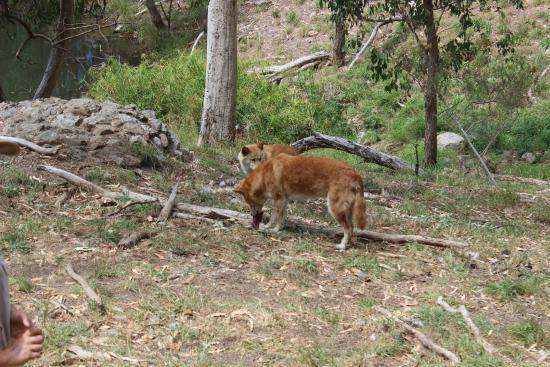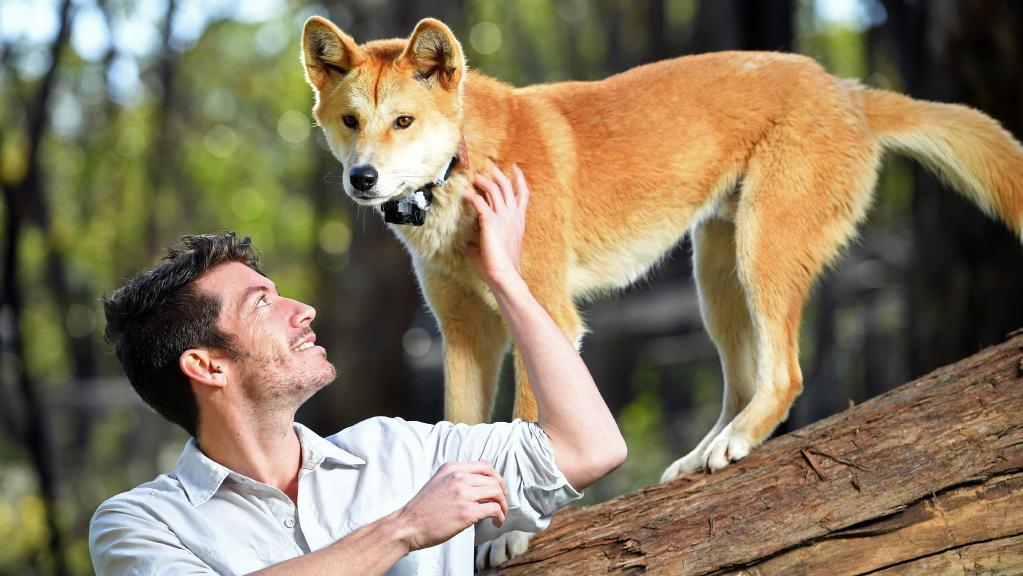The first image is the image on the left, the second image is the image on the right. Considering the images on both sides, is "There are exactly three dogs in total." valid? Answer yes or no. Yes. 